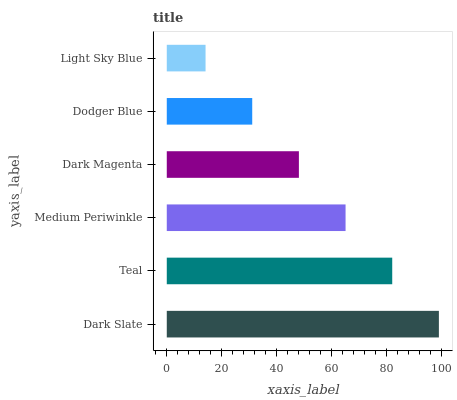Is Light Sky Blue the minimum?
Answer yes or no. Yes. Is Dark Slate the maximum?
Answer yes or no. Yes. Is Teal the minimum?
Answer yes or no. No. Is Teal the maximum?
Answer yes or no. No. Is Dark Slate greater than Teal?
Answer yes or no. Yes. Is Teal less than Dark Slate?
Answer yes or no. Yes. Is Teal greater than Dark Slate?
Answer yes or no. No. Is Dark Slate less than Teal?
Answer yes or no. No. Is Medium Periwinkle the high median?
Answer yes or no. Yes. Is Dark Magenta the low median?
Answer yes or no. Yes. Is Light Sky Blue the high median?
Answer yes or no. No. Is Medium Periwinkle the low median?
Answer yes or no. No. 